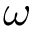Convert formula to latex. <formula><loc_0><loc_0><loc_500><loc_500>\omega</formula> 